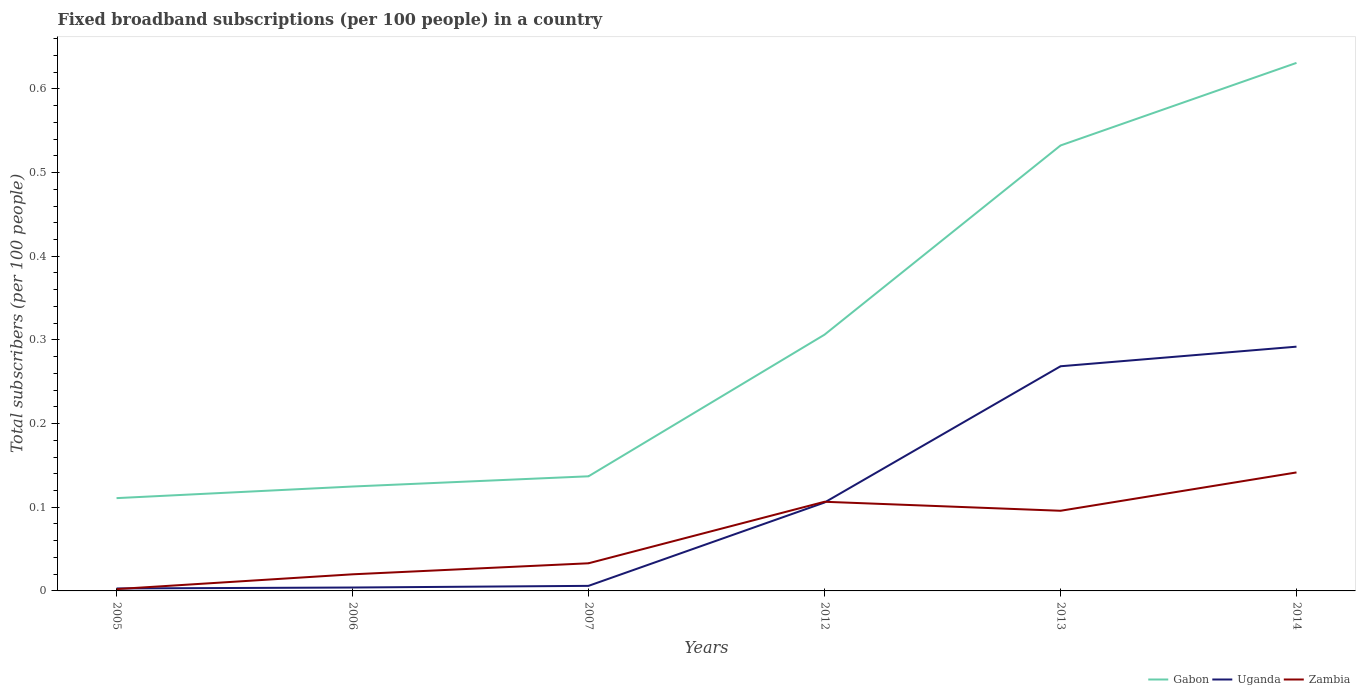Across all years, what is the maximum number of broadband subscriptions in Gabon?
Provide a short and direct response. 0.11. What is the total number of broadband subscriptions in Uganda in the graph?
Offer a terse response. -0.26. What is the difference between the highest and the second highest number of broadband subscriptions in Uganda?
Make the answer very short. 0.29. What is the difference between the highest and the lowest number of broadband subscriptions in Gabon?
Offer a very short reply. 2. Is the number of broadband subscriptions in Gabon strictly greater than the number of broadband subscriptions in Zambia over the years?
Provide a succinct answer. No. How many lines are there?
Your answer should be compact. 3. What is the difference between two consecutive major ticks on the Y-axis?
Your answer should be compact. 0.1. Are the values on the major ticks of Y-axis written in scientific E-notation?
Keep it short and to the point. No. Does the graph contain any zero values?
Keep it short and to the point. No. Does the graph contain grids?
Make the answer very short. No. How many legend labels are there?
Your answer should be compact. 3. What is the title of the graph?
Give a very brief answer. Fixed broadband subscriptions (per 100 people) in a country. What is the label or title of the X-axis?
Provide a succinct answer. Years. What is the label or title of the Y-axis?
Ensure brevity in your answer.  Total subscribers (per 100 people). What is the Total subscribers (per 100 people) of Gabon in 2005?
Your response must be concise. 0.11. What is the Total subscribers (per 100 people) of Uganda in 2005?
Offer a very short reply. 0. What is the Total subscribers (per 100 people) in Zambia in 2005?
Ensure brevity in your answer.  0. What is the Total subscribers (per 100 people) of Gabon in 2006?
Provide a short and direct response. 0.12. What is the Total subscribers (per 100 people) of Uganda in 2006?
Keep it short and to the point. 0. What is the Total subscribers (per 100 people) of Zambia in 2006?
Ensure brevity in your answer.  0.02. What is the Total subscribers (per 100 people) in Gabon in 2007?
Your answer should be very brief. 0.14. What is the Total subscribers (per 100 people) of Uganda in 2007?
Give a very brief answer. 0.01. What is the Total subscribers (per 100 people) in Zambia in 2007?
Make the answer very short. 0.03. What is the Total subscribers (per 100 people) of Gabon in 2012?
Your answer should be compact. 0.31. What is the Total subscribers (per 100 people) in Uganda in 2012?
Provide a succinct answer. 0.11. What is the Total subscribers (per 100 people) of Zambia in 2012?
Offer a very short reply. 0.11. What is the Total subscribers (per 100 people) in Gabon in 2013?
Your answer should be compact. 0.53. What is the Total subscribers (per 100 people) in Uganda in 2013?
Keep it short and to the point. 0.27. What is the Total subscribers (per 100 people) of Zambia in 2013?
Your answer should be very brief. 0.1. What is the Total subscribers (per 100 people) of Gabon in 2014?
Your answer should be very brief. 0.63. What is the Total subscribers (per 100 people) of Uganda in 2014?
Give a very brief answer. 0.29. What is the Total subscribers (per 100 people) of Zambia in 2014?
Give a very brief answer. 0.14. Across all years, what is the maximum Total subscribers (per 100 people) in Gabon?
Provide a succinct answer. 0.63. Across all years, what is the maximum Total subscribers (per 100 people) in Uganda?
Your response must be concise. 0.29. Across all years, what is the maximum Total subscribers (per 100 people) in Zambia?
Provide a short and direct response. 0.14. Across all years, what is the minimum Total subscribers (per 100 people) in Gabon?
Offer a terse response. 0.11. Across all years, what is the minimum Total subscribers (per 100 people) in Uganda?
Offer a very short reply. 0. Across all years, what is the minimum Total subscribers (per 100 people) in Zambia?
Offer a very short reply. 0. What is the total Total subscribers (per 100 people) in Gabon in the graph?
Your answer should be compact. 1.84. What is the total Total subscribers (per 100 people) in Uganda in the graph?
Your response must be concise. 0.68. What is the total Total subscribers (per 100 people) of Zambia in the graph?
Your answer should be very brief. 0.4. What is the difference between the Total subscribers (per 100 people) of Gabon in 2005 and that in 2006?
Keep it short and to the point. -0.01. What is the difference between the Total subscribers (per 100 people) in Uganda in 2005 and that in 2006?
Your answer should be compact. -0. What is the difference between the Total subscribers (per 100 people) of Zambia in 2005 and that in 2006?
Offer a very short reply. -0.02. What is the difference between the Total subscribers (per 100 people) in Gabon in 2005 and that in 2007?
Give a very brief answer. -0.03. What is the difference between the Total subscribers (per 100 people) in Uganda in 2005 and that in 2007?
Provide a short and direct response. -0. What is the difference between the Total subscribers (per 100 people) of Zambia in 2005 and that in 2007?
Offer a very short reply. -0.03. What is the difference between the Total subscribers (per 100 people) of Gabon in 2005 and that in 2012?
Give a very brief answer. -0.2. What is the difference between the Total subscribers (per 100 people) of Uganda in 2005 and that in 2012?
Keep it short and to the point. -0.1. What is the difference between the Total subscribers (per 100 people) of Zambia in 2005 and that in 2012?
Keep it short and to the point. -0.1. What is the difference between the Total subscribers (per 100 people) of Gabon in 2005 and that in 2013?
Your answer should be very brief. -0.42. What is the difference between the Total subscribers (per 100 people) in Uganda in 2005 and that in 2013?
Provide a short and direct response. -0.27. What is the difference between the Total subscribers (per 100 people) of Zambia in 2005 and that in 2013?
Provide a succinct answer. -0.09. What is the difference between the Total subscribers (per 100 people) of Gabon in 2005 and that in 2014?
Offer a terse response. -0.52. What is the difference between the Total subscribers (per 100 people) in Uganda in 2005 and that in 2014?
Keep it short and to the point. -0.29. What is the difference between the Total subscribers (per 100 people) of Zambia in 2005 and that in 2014?
Your answer should be compact. -0.14. What is the difference between the Total subscribers (per 100 people) in Gabon in 2006 and that in 2007?
Your answer should be compact. -0.01. What is the difference between the Total subscribers (per 100 people) of Uganda in 2006 and that in 2007?
Your response must be concise. -0. What is the difference between the Total subscribers (per 100 people) in Zambia in 2006 and that in 2007?
Make the answer very short. -0.01. What is the difference between the Total subscribers (per 100 people) in Gabon in 2006 and that in 2012?
Offer a terse response. -0.18. What is the difference between the Total subscribers (per 100 people) in Uganda in 2006 and that in 2012?
Your answer should be very brief. -0.1. What is the difference between the Total subscribers (per 100 people) of Zambia in 2006 and that in 2012?
Offer a very short reply. -0.09. What is the difference between the Total subscribers (per 100 people) in Gabon in 2006 and that in 2013?
Your response must be concise. -0.41. What is the difference between the Total subscribers (per 100 people) of Uganda in 2006 and that in 2013?
Provide a succinct answer. -0.26. What is the difference between the Total subscribers (per 100 people) in Zambia in 2006 and that in 2013?
Make the answer very short. -0.08. What is the difference between the Total subscribers (per 100 people) of Gabon in 2006 and that in 2014?
Your response must be concise. -0.51. What is the difference between the Total subscribers (per 100 people) in Uganda in 2006 and that in 2014?
Make the answer very short. -0.29. What is the difference between the Total subscribers (per 100 people) of Zambia in 2006 and that in 2014?
Provide a succinct answer. -0.12. What is the difference between the Total subscribers (per 100 people) in Gabon in 2007 and that in 2012?
Give a very brief answer. -0.17. What is the difference between the Total subscribers (per 100 people) of Uganda in 2007 and that in 2012?
Provide a succinct answer. -0.1. What is the difference between the Total subscribers (per 100 people) in Zambia in 2007 and that in 2012?
Ensure brevity in your answer.  -0.07. What is the difference between the Total subscribers (per 100 people) of Gabon in 2007 and that in 2013?
Your answer should be compact. -0.4. What is the difference between the Total subscribers (per 100 people) of Uganda in 2007 and that in 2013?
Make the answer very short. -0.26. What is the difference between the Total subscribers (per 100 people) of Zambia in 2007 and that in 2013?
Offer a very short reply. -0.06. What is the difference between the Total subscribers (per 100 people) of Gabon in 2007 and that in 2014?
Offer a very short reply. -0.49. What is the difference between the Total subscribers (per 100 people) in Uganda in 2007 and that in 2014?
Provide a short and direct response. -0.29. What is the difference between the Total subscribers (per 100 people) in Zambia in 2007 and that in 2014?
Give a very brief answer. -0.11. What is the difference between the Total subscribers (per 100 people) in Gabon in 2012 and that in 2013?
Provide a succinct answer. -0.23. What is the difference between the Total subscribers (per 100 people) of Uganda in 2012 and that in 2013?
Offer a terse response. -0.16. What is the difference between the Total subscribers (per 100 people) in Zambia in 2012 and that in 2013?
Your response must be concise. 0.01. What is the difference between the Total subscribers (per 100 people) in Gabon in 2012 and that in 2014?
Your answer should be compact. -0.32. What is the difference between the Total subscribers (per 100 people) of Uganda in 2012 and that in 2014?
Your response must be concise. -0.19. What is the difference between the Total subscribers (per 100 people) in Zambia in 2012 and that in 2014?
Offer a terse response. -0.04. What is the difference between the Total subscribers (per 100 people) of Gabon in 2013 and that in 2014?
Ensure brevity in your answer.  -0.1. What is the difference between the Total subscribers (per 100 people) of Uganda in 2013 and that in 2014?
Your answer should be compact. -0.02. What is the difference between the Total subscribers (per 100 people) in Zambia in 2013 and that in 2014?
Offer a very short reply. -0.05. What is the difference between the Total subscribers (per 100 people) in Gabon in 2005 and the Total subscribers (per 100 people) in Uganda in 2006?
Offer a very short reply. 0.11. What is the difference between the Total subscribers (per 100 people) of Gabon in 2005 and the Total subscribers (per 100 people) of Zambia in 2006?
Make the answer very short. 0.09. What is the difference between the Total subscribers (per 100 people) of Uganda in 2005 and the Total subscribers (per 100 people) of Zambia in 2006?
Your response must be concise. -0.02. What is the difference between the Total subscribers (per 100 people) of Gabon in 2005 and the Total subscribers (per 100 people) of Uganda in 2007?
Make the answer very short. 0.1. What is the difference between the Total subscribers (per 100 people) in Gabon in 2005 and the Total subscribers (per 100 people) in Zambia in 2007?
Ensure brevity in your answer.  0.08. What is the difference between the Total subscribers (per 100 people) of Uganda in 2005 and the Total subscribers (per 100 people) of Zambia in 2007?
Keep it short and to the point. -0.03. What is the difference between the Total subscribers (per 100 people) of Gabon in 2005 and the Total subscribers (per 100 people) of Uganda in 2012?
Your answer should be compact. 0.01. What is the difference between the Total subscribers (per 100 people) of Gabon in 2005 and the Total subscribers (per 100 people) of Zambia in 2012?
Offer a terse response. 0. What is the difference between the Total subscribers (per 100 people) of Uganda in 2005 and the Total subscribers (per 100 people) of Zambia in 2012?
Your response must be concise. -0.1. What is the difference between the Total subscribers (per 100 people) in Gabon in 2005 and the Total subscribers (per 100 people) in Uganda in 2013?
Make the answer very short. -0.16. What is the difference between the Total subscribers (per 100 people) of Gabon in 2005 and the Total subscribers (per 100 people) of Zambia in 2013?
Your response must be concise. 0.02. What is the difference between the Total subscribers (per 100 people) of Uganda in 2005 and the Total subscribers (per 100 people) of Zambia in 2013?
Your answer should be compact. -0.09. What is the difference between the Total subscribers (per 100 people) of Gabon in 2005 and the Total subscribers (per 100 people) of Uganda in 2014?
Provide a short and direct response. -0.18. What is the difference between the Total subscribers (per 100 people) of Gabon in 2005 and the Total subscribers (per 100 people) of Zambia in 2014?
Make the answer very short. -0.03. What is the difference between the Total subscribers (per 100 people) of Uganda in 2005 and the Total subscribers (per 100 people) of Zambia in 2014?
Your response must be concise. -0.14. What is the difference between the Total subscribers (per 100 people) of Gabon in 2006 and the Total subscribers (per 100 people) of Uganda in 2007?
Your answer should be compact. 0.12. What is the difference between the Total subscribers (per 100 people) of Gabon in 2006 and the Total subscribers (per 100 people) of Zambia in 2007?
Ensure brevity in your answer.  0.09. What is the difference between the Total subscribers (per 100 people) in Uganda in 2006 and the Total subscribers (per 100 people) in Zambia in 2007?
Offer a terse response. -0.03. What is the difference between the Total subscribers (per 100 people) in Gabon in 2006 and the Total subscribers (per 100 people) in Uganda in 2012?
Your answer should be very brief. 0.02. What is the difference between the Total subscribers (per 100 people) in Gabon in 2006 and the Total subscribers (per 100 people) in Zambia in 2012?
Offer a terse response. 0.02. What is the difference between the Total subscribers (per 100 people) in Uganda in 2006 and the Total subscribers (per 100 people) in Zambia in 2012?
Offer a very short reply. -0.1. What is the difference between the Total subscribers (per 100 people) in Gabon in 2006 and the Total subscribers (per 100 people) in Uganda in 2013?
Provide a succinct answer. -0.14. What is the difference between the Total subscribers (per 100 people) of Gabon in 2006 and the Total subscribers (per 100 people) of Zambia in 2013?
Offer a terse response. 0.03. What is the difference between the Total subscribers (per 100 people) in Uganda in 2006 and the Total subscribers (per 100 people) in Zambia in 2013?
Give a very brief answer. -0.09. What is the difference between the Total subscribers (per 100 people) of Gabon in 2006 and the Total subscribers (per 100 people) of Uganda in 2014?
Offer a terse response. -0.17. What is the difference between the Total subscribers (per 100 people) in Gabon in 2006 and the Total subscribers (per 100 people) in Zambia in 2014?
Ensure brevity in your answer.  -0.02. What is the difference between the Total subscribers (per 100 people) of Uganda in 2006 and the Total subscribers (per 100 people) of Zambia in 2014?
Your answer should be compact. -0.14. What is the difference between the Total subscribers (per 100 people) of Gabon in 2007 and the Total subscribers (per 100 people) of Uganda in 2012?
Provide a short and direct response. 0.03. What is the difference between the Total subscribers (per 100 people) in Gabon in 2007 and the Total subscribers (per 100 people) in Zambia in 2012?
Your answer should be compact. 0.03. What is the difference between the Total subscribers (per 100 people) in Uganda in 2007 and the Total subscribers (per 100 people) in Zambia in 2012?
Keep it short and to the point. -0.1. What is the difference between the Total subscribers (per 100 people) in Gabon in 2007 and the Total subscribers (per 100 people) in Uganda in 2013?
Make the answer very short. -0.13. What is the difference between the Total subscribers (per 100 people) of Gabon in 2007 and the Total subscribers (per 100 people) of Zambia in 2013?
Your answer should be compact. 0.04. What is the difference between the Total subscribers (per 100 people) in Uganda in 2007 and the Total subscribers (per 100 people) in Zambia in 2013?
Your response must be concise. -0.09. What is the difference between the Total subscribers (per 100 people) in Gabon in 2007 and the Total subscribers (per 100 people) in Uganda in 2014?
Provide a succinct answer. -0.15. What is the difference between the Total subscribers (per 100 people) in Gabon in 2007 and the Total subscribers (per 100 people) in Zambia in 2014?
Your answer should be very brief. -0. What is the difference between the Total subscribers (per 100 people) of Uganda in 2007 and the Total subscribers (per 100 people) of Zambia in 2014?
Ensure brevity in your answer.  -0.14. What is the difference between the Total subscribers (per 100 people) in Gabon in 2012 and the Total subscribers (per 100 people) in Uganda in 2013?
Ensure brevity in your answer.  0.04. What is the difference between the Total subscribers (per 100 people) of Gabon in 2012 and the Total subscribers (per 100 people) of Zambia in 2013?
Your answer should be very brief. 0.21. What is the difference between the Total subscribers (per 100 people) of Uganda in 2012 and the Total subscribers (per 100 people) of Zambia in 2013?
Offer a very short reply. 0.01. What is the difference between the Total subscribers (per 100 people) of Gabon in 2012 and the Total subscribers (per 100 people) of Uganda in 2014?
Give a very brief answer. 0.01. What is the difference between the Total subscribers (per 100 people) in Gabon in 2012 and the Total subscribers (per 100 people) in Zambia in 2014?
Give a very brief answer. 0.16. What is the difference between the Total subscribers (per 100 people) of Uganda in 2012 and the Total subscribers (per 100 people) of Zambia in 2014?
Give a very brief answer. -0.04. What is the difference between the Total subscribers (per 100 people) of Gabon in 2013 and the Total subscribers (per 100 people) of Uganda in 2014?
Give a very brief answer. 0.24. What is the difference between the Total subscribers (per 100 people) of Gabon in 2013 and the Total subscribers (per 100 people) of Zambia in 2014?
Offer a very short reply. 0.39. What is the difference between the Total subscribers (per 100 people) of Uganda in 2013 and the Total subscribers (per 100 people) of Zambia in 2014?
Provide a short and direct response. 0.13. What is the average Total subscribers (per 100 people) in Gabon per year?
Your answer should be compact. 0.31. What is the average Total subscribers (per 100 people) of Uganda per year?
Ensure brevity in your answer.  0.11. What is the average Total subscribers (per 100 people) of Zambia per year?
Your answer should be compact. 0.07. In the year 2005, what is the difference between the Total subscribers (per 100 people) of Gabon and Total subscribers (per 100 people) of Uganda?
Provide a short and direct response. 0.11. In the year 2005, what is the difference between the Total subscribers (per 100 people) of Gabon and Total subscribers (per 100 people) of Zambia?
Your answer should be very brief. 0.11. In the year 2005, what is the difference between the Total subscribers (per 100 people) of Uganda and Total subscribers (per 100 people) of Zambia?
Your response must be concise. 0. In the year 2006, what is the difference between the Total subscribers (per 100 people) of Gabon and Total subscribers (per 100 people) of Uganda?
Your response must be concise. 0.12. In the year 2006, what is the difference between the Total subscribers (per 100 people) of Gabon and Total subscribers (per 100 people) of Zambia?
Provide a short and direct response. 0.1. In the year 2006, what is the difference between the Total subscribers (per 100 people) in Uganda and Total subscribers (per 100 people) in Zambia?
Give a very brief answer. -0.02. In the year 2007, what is the difference between the Total subscribers (per 100 people) of Gabon and Total subscribers (per 100 people) of Uganda?
Your answer should be compact. 0.13. In the year 2007, what is the difference between the Total subscribers (per 100 people) in Gabon and Total subscribers (per 100 people) in Zambia?
Offer a very short reply. 0.1. In the year 2007, what is the difference between the Total subscribers (per 100 people) in Uganda and Total subscribers (per 100 people) in Zambia?
Ensure brevity in your answer.  -0.03. In the year 2012, what is the difference between the Total subscribers (per 100 people) of Gabon and Total subscribers (per 100 people) of Uganda?
Your response must be concise. 0.2. In the year 2012, what is the difference between the Total subscribers (per 100 people) of Gabon and Total subscribers (per 100 people) of Zambia?
Make the answer very short. 0.2. In the year 2012, what is the difference between the Total subscribers (per 100 people) in Uganda and Total subscribers (per 100 people) in Zambia?
Give a very brief answer. -0. In the year 2013, what is the difference between the Total subscribers (per 100 people) of Gabon and Total subscribers (per 100 people) of Uganda?
Provide a short and direct response. 0.26. In the year 2013, what is the difference between the Total subscribers (per 100 people) in Gabon and Total subscribers (per 100 people) in Zambia?
Provide a short and direct response. 0.44. In the year 2013, what is the difference between the Total subscribers (per 100 people) in Uganda and Total subscribers (per 100 people) in Zambia?
Provide a short and direct response. 0.17. In the year 2014, what is the difference between the Total subscribers (per 100 people) in Gabon and Total subscribers (per 100 people) in Uganda?
Your response must be concise. 0.34. In the year 2014, what is the difference between the Total subscribers (per 100 people) in Gabon and Total subscribers (per 100 people) in Zambia?
Your answer should be compact. 0.49. In the year 2014, what is the difference between the Total subscribers (per 100 people) of Uganda and Total subscribers (per 100 people) of Zambia?
Your answer should be very brief. 0.15. What is the ratio of the Total subscribers (per 100 people) in Gabon in 2005 to that in 2006?
Provide a short and direct response. 0.89. What is the ratio of the Total subscribers (per 100 people) of Uganda in 2005 to that in 2006?
Your answer should be compact. 0.73. What is the ratio of the Total subscribers (per 100 people) of Zambia in 2005 to that in 2006?
Provide a short and direct response. 0.11. What is the ratio of the Total subscribers (per 100 people) of Gabon in 2005 to that in 2007?
Provide a succinct answer. 0.81. What is the ratio of the Total subscribers (per 100 people) of Uganda in 2005 to that in 2007?
Your answer should be compact. 0.49. What is the ratio of the Total subscribers (per 100 people) in Zambia in 2005 to that in 2007?
Keep it short and to the point. 0.07. What is the ratio of the Total subscribers (per 100 people) in Gabon in 2005 to that in 2012?
Keep it short and to the point. 0.36. What is the ratio of the Total subscribers (per 100 people) in Uganda in 2005 to that in 2012?
Make the answer very short. 0.03. What is the ratio of the Total subscribers (per 100 people) in Zambia in 2005 to that in 2012?
Ensure brevity in your answer.  0.02. What is the ratio of the Total subscribers (per 100 people) of Gabon in 2005 to that in 2013?
Make the answer very short. 0.21. What is the ratio of the Total subscribers (per 100 people) in Uganda in 2005 to that in 2013?
Offer a terse response. 0.01. What is the ratio of the Total subscribers (per 100 people) in Zambia in 2005 to that in 2013?
Your answer should be very brief. 0.02. What is the ratio of the Total subscribers (per 100 people) in Gabon in 2005 to that in 2014?
Your response must be concise. 0.18. What is the ratio of the Total subscribers (per 100 people) of Uganda in 2005 to that in 2014?
Offer a terse response. 0.01. What is the ratio of the Total subscribers (per 100 people) in Zambia in 2005 to that in 2014?
Provide a succinct answer. 0.02. What is the ratio of the Total subscribers (per 100 people) of Gabon in 2006 to that in 2007?
Offer a terse response. 0.91. What is the ratio of the Total subscribers (per 100 people) in Uganda in 2006 to that in 2007?
Your answer should be compact. 0.67. What is the ratio of the Total subscribers (per 100 people) in Zambia in 2006 to that in 2007?
Offer a terse response. 0.6. What is the ratio of the Total subscribers (per 100 people) of Gabon in 2006 to that in 2012?
Give a very brief answer. 0.41. What is the ratio of the Total subscribers (per 100 people) of Uganda in 2006 to that in 2012?
Give a very brief answer. 0.04. What is the ratio of the Total subscribers (per 100 people) of Zambia in 2006 to that in 2012?
Provide a succinct answer. 0.19. What is the ratio of the Total subscribers (per 100 people) of Gabon in 2006 to that in 2013?
Your answer should be very brief. 0.23. What is the ratio of the Total subscribers (per 100 people) of Uganda in 2006 to that in 2013?
Provide a short and direct response. 0.02. What is the ratio of the Total subscribers (per 100 people) of Zambia in 2006 to that in 2013?
Your response must be concise. 0.21. What is the ratio of the Total subscribers (per 100 people) of Gabon in 2006 to that in 2014?
Give a very brief answer. 0.2. What is the ratio of the Total subscribers (per 100 people) of Uganda in 2006 to that in 2014?
Your answer should be compact. 0.01. What is the ratio of the Total subscribers (per 100 people) in Zambia in 2006 to that in 2014?
Your answer should be compact. 0.14. What is the ratio of the Total subscribers (per 100 people) in Gabon in 2007 to that in 2012?
Ensure brevity in your answer.  0.45. What is the ratio of the Total subscribers (per 100 people) of Uganda in 2007 to that in 2012?
Offer a very short reply. 0.06. What is the ratio of the Total subscribers (per 100 people) in Zambia in 2007 to that in 2012?
Keep it short and to the point. 0.31. What is the ratio of the Total subscribers (per 100 people) in Gabon in 2007 to that in 2013?
Your answer should be compact. 0.26. What is the ratio of the Total subscribers (per 100 people) in Uganda in 2007 to that in 2013?
Keep it short and to the point. 0.02. What is the ratio of the Total subscribers (per 100 people) in Zambia in 2007 to that in 2013?
Give a very brief answer. 0.34. What is the ratio of the Total subscribers (per 100 people) of Gabon in 2007 to that in 2014?
Give a very brief answer. 0.22. What is the ratio of the Total subscribers (per 100 people) in Uganda in 2007 to that in 2014?
Give a very brief answer. 0.02. What is the ratio of the Total subscribers (per 100 people) of Zambia in 2007 to that in 2014?
Your response must be concise. 0.23. What is the ratio of the Total subscribers (per 100 people) of Gabon in 2012 to that in 2013?
Keep it short and to the point. 0.58. What is the ratio of the Total subscribers (per 100 people) of Uganda in 2012 to that in 2013?
Offer a terse response. 0.39. What is the ratio of the Total subscribers (per 100 people) of Zambia in 2012 to that in 2013?
Your answer should be compact. 1.11. What is the ratio of the Total subscribers (per 100 people) of Gabon in 2012 to that in 2014?
Your answer should be very brief. 0.49. What is the ratio of the Total subscribers (per 100 people) in Uganda in 2012 to that in 2014?
Provide a short and direct response. 0.36. What is the ratio of the Total subscribers (per 100 people) in Zambia in 2012 to that in 2014?
Make the answer very short. 0.75. What is the ratio of the Total subscribers (per 100 people) in Gabon in 2013 to that in 2014?
Your answer should be very brief. 0.84. What is the ratio of the Total subscribers (per 100 people) in Uganda in 2013 to that in 2014?
Offer a very short reply. 0.92. What is the ratio of the Total subscribers (per 100 people) in Zambia in 2013 to that in 2014?
Make the answer very short. 0.68. What is the difference between the highest and the second highest Total subscribers (per 100 people) in Gabon?
Give a very brief answer. 0.1. What is the difference between the highest and the second highest Total subscribers (per 100 people) in Uganda?
Ensure brevity in your answer.  0.02. What is the difference between the highest and the second highest Total subscribers (per 100 people) of Zambia?
Your answer should be compact. 0.04. What is the difference between the highest and the lowest Total subscribers (per 100 people) in Gabon?
Your answer should be compact. 0.52. What is the difference between the highest and the lowest Total subscribers (per 100 people) of Uganda?
Provide a short and direct response. 0.29. What is the difference between the highest and the lowest Total subscribers (per 100 people) in Zambia?
Give a very brief answer. 0.14. 